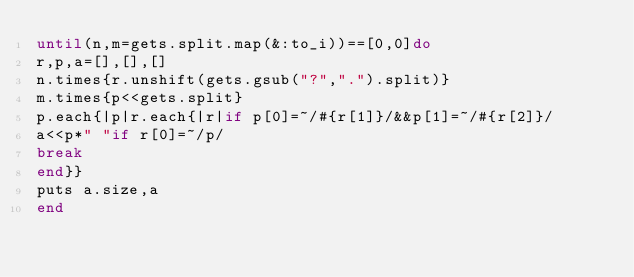Convert code to text. <code><loc_0><loc_0><loc_500><loc_500><_Ruby_>until(n,m=gets.split.map(&:to_i))==[0,0]do
r,p,a=[],[],[]
n.times{r.unshift(gets.gsub("?",".").split)}
m.times{p<<gets.split}
p.each{|p|r.each{|r|if p[0]=~/#{r[1]}/&&p[1]=~/#{r[2]}/
a<<p*" "if r[0]=~/p/
break
end}}
puts a.size,a
end</code> 